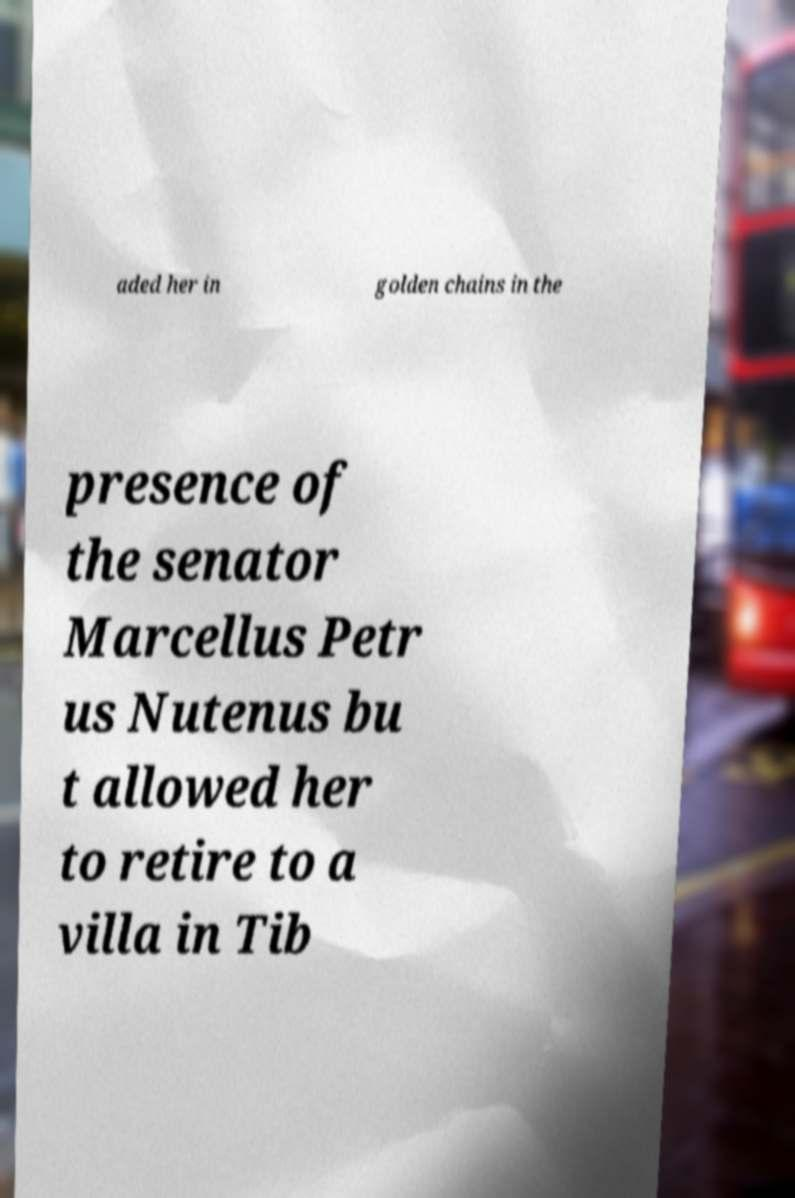Could you assist in decoding the text presented in this image and type it out clearly? aded her in golden chains in the presence of the senator Marcellus Petr us Nutenus bu t allowed her to retire to a villa in Tib 